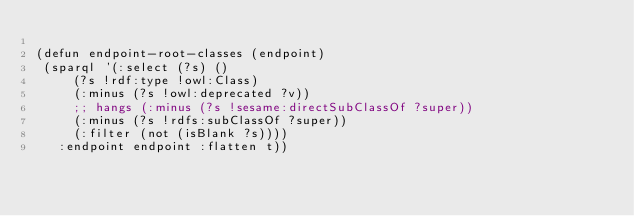<code> <loc_0><loc_0><loc_500><loc_500><_Lisp_>
(defun endpoint-root-classes (endpoint)
 (sparql '(:select (?s) ()
	   (?s !rdf:type !owl:Class)
	   (:minus (?s !owl:deprecated ?v))
	   ;; hangs (:minus (?s !sesame:directSubClassOf ?super)) 
	   (:minus (?s !rdfs:subClassOf ?super))
	   (:filter (not (isBlank ?s))))
	 :endpoint endpoint :flatten t))


</code> 